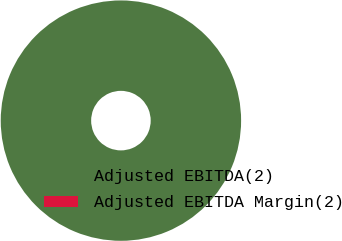<chart> <loc_0><loc_0><loc_500><loc_500><pie_chart><fcel>Adjusted EBITDA(2)<fcel>Adjusted EBITDA Margin(2)<nl><fcel>100.0%<fcel>0.0%<nl></chart> 